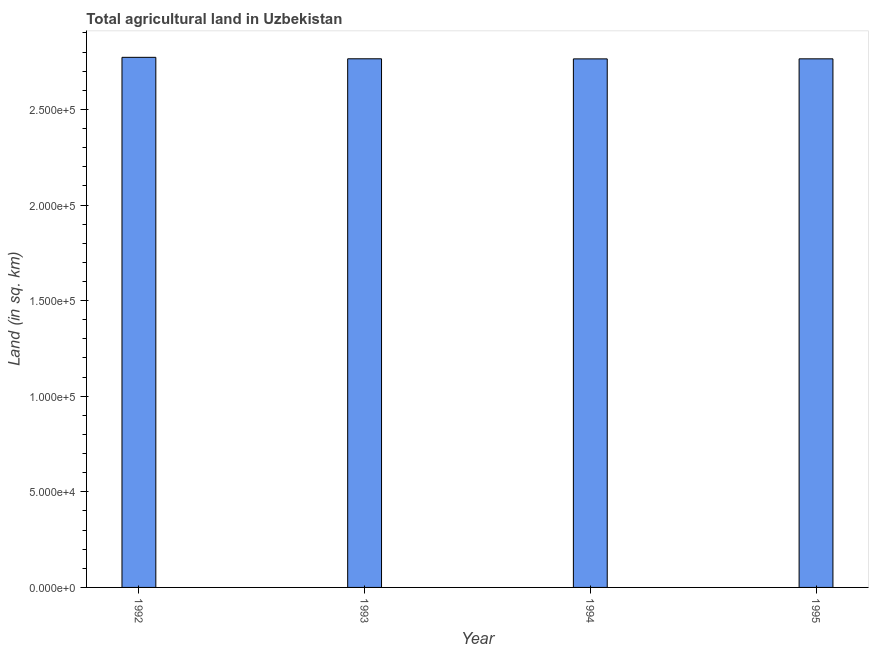Does the graph contain grids?
Give a very brief answer. No. What is the title of the graph?
Provide a short and direct response. Total agricultural land in Uzbekistan. What is the label or title of the Y-axis?
Provide a succinct answer. Land (in sq. km). What is the agricultural land in 1993?
Provide a succinct answer. 2.76e+05. Across all years, what is the maximum agricultural land?
Make the answer very short. 2.77e+05. Across all years, what is the minimum agricultural land?
Offer a very short reply. 2.76e+05. In which year was the agricultural land maximum?
Provide a succinct answer. 1992. In which year was the agricultural land minimum?
Ensure brevity in your answer.  1994. What is the sum of the agricultural land?
Your answer should be compact. 1.11e+06. What is the difference between the agricultural land in 1992 and 1995?
Give a very brief answer. 790. What is the average agricultural land per year?
Provide a short and direct response. 2.77e+05. What is the median agricultural land?
Ensure brevity in your answer.  2.76e+05. In how many years, is the agricultural land greater than 80000 sq. km?
Provide a succinct answer. 4. What is the ratio of the agricultural land in 1992 to that in 1995?
Your response must be concise. 1. Is the agricultural land in 1994 less than that in 1995?
Your response must be concise. Yes. What is the difference between the highest and the second highest agricultural land?
Ensure brevity in your answer.  760. Is the sum of the agricultural land in 1992 and 1995 greater than the maximum agricultural land across all years?
Ensure brevity in your answer.  Yes. What is the difference between the highest and the lowest agricultural land?
Your response must be concise. 810. In how many years, is the agricultural land greater than the average agricultural land taken over all years?
Your answer should be very brief. 1. How many years are there in the graph?
Make the answer very short. 4. Are the values on the major ticks of Y-axis written in scientific E-notation?
Provide a succinct answer. Yes. What is the Land (in sq. km) of 1992?
Provide a succinct answer. 2.77e+05. What is the Land (in sq. km) in 1993?
Keep it short and to the point. 2.76e+05. What is the Land (in sq. km) of 1994?
Keep it short and to the point. 2.76e+05. What is the Land (in sq. km) of 1995?
Give a very brief answer. 2.76e+05. What is the difference between the Land (in sq. km) in 1992 and 1993?
Give a very brief answer. 760. What is the difference between the Land (in sq. km) in 1992 and 1994?
Your answer should be compact. 810. What is the difference between the Land (in sq. km) in 1992 and 1995?
Provide a short and direct response. 790. What is the difference between the Land (in sq. km) in 1993 and 1994?
Your response must be concise. 50. What is the difference between the Land (in sq. km) in 1993 and 1995?
Offer a very short reply. 30. What is the ratio of the Land (in sq. km) in 1992 to that in 1994?
Offer a terse response. 1. What is the ratio of the Land (in sq. km) in 1992 to that in 1995?
Offer a very short reply. 1. What is the ratio of the Land (in sq. km) in 1994 to that in 1995?
Provide a short and direct response. 1. 